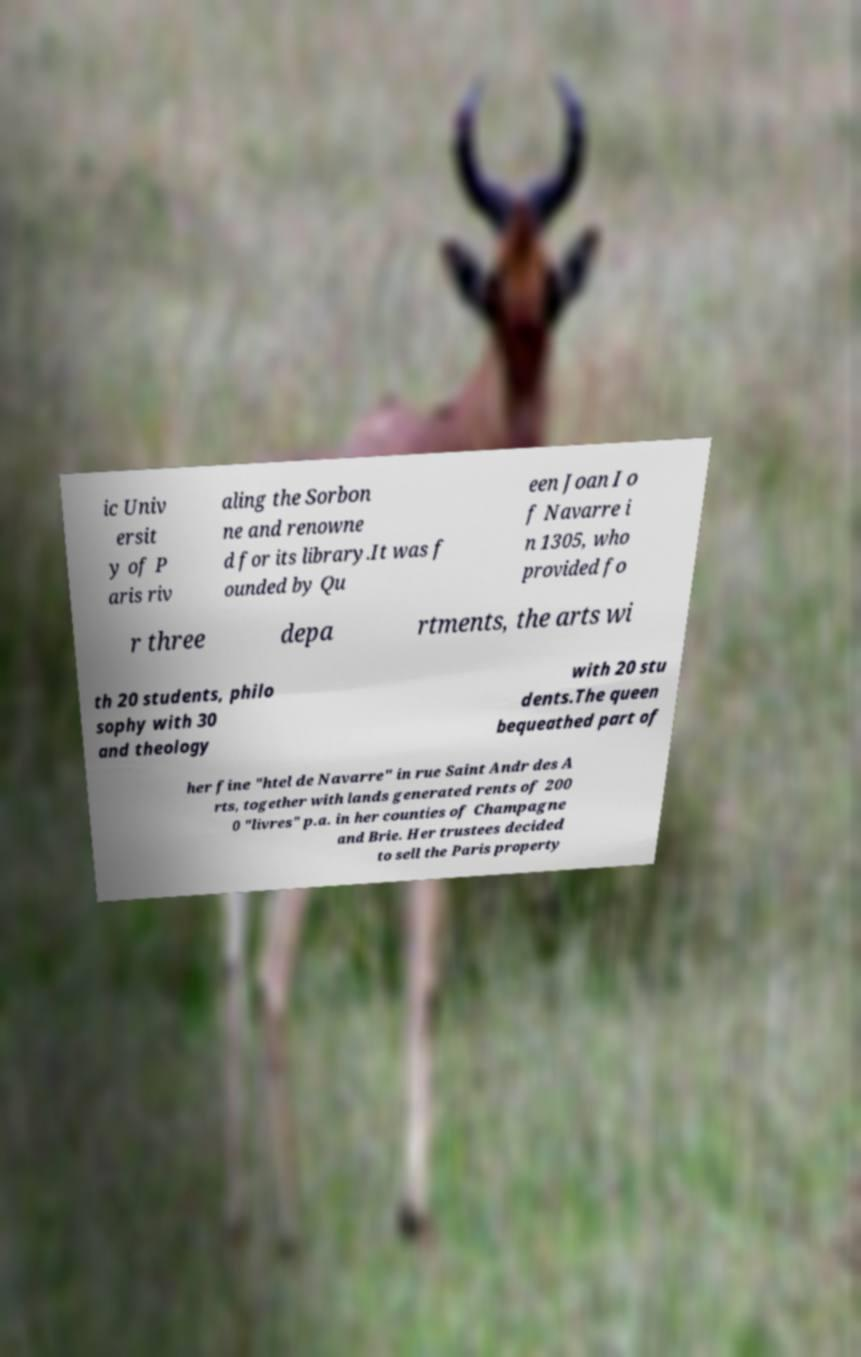Could you assist in decoding the text presented in this image and type it out clearly? ic Univ ersit y of P aris riv aling the Sorbon ne and renowne d for its library.It was f ounded by Qu een Joan I o f Navarre i n 1305, who provided fo r three depa rtments, the arts wi th 20 students, philo sophy with 30 and theology with 20 stu dents.The queen bequeathed part of her fine "htel de Navarre" in rue Saint Andr des A rts, together with lands generated rents of 200 0 "livres" p.a. in her counties of Champagne and Brie. Her trustees decided to sell the Paris property 